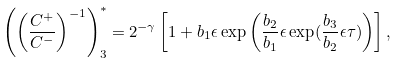<formula> <loc_0><loc_0><loc_500><loc_500>\left ( \left ( \frac { C ^ { + } } { C ^ { - } } \right ) ^ { - 1 } \right ) _ { 3 } ^ { * } = 2 ^ { - \gamma } \left [ 1 + b _ { 1 } \epsilon \exp \left ( \frac { b _ { 2 } } { b _ { 1 } } \epsilon \exp ( \frac { b _ { 3 } } { b _ { 2 } } \epsilon \tau ) \right ) \right ] ,</formula> 